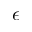<formula> <loc_0><loc_0><loc_500><loc_500>\epsilon</formula> 